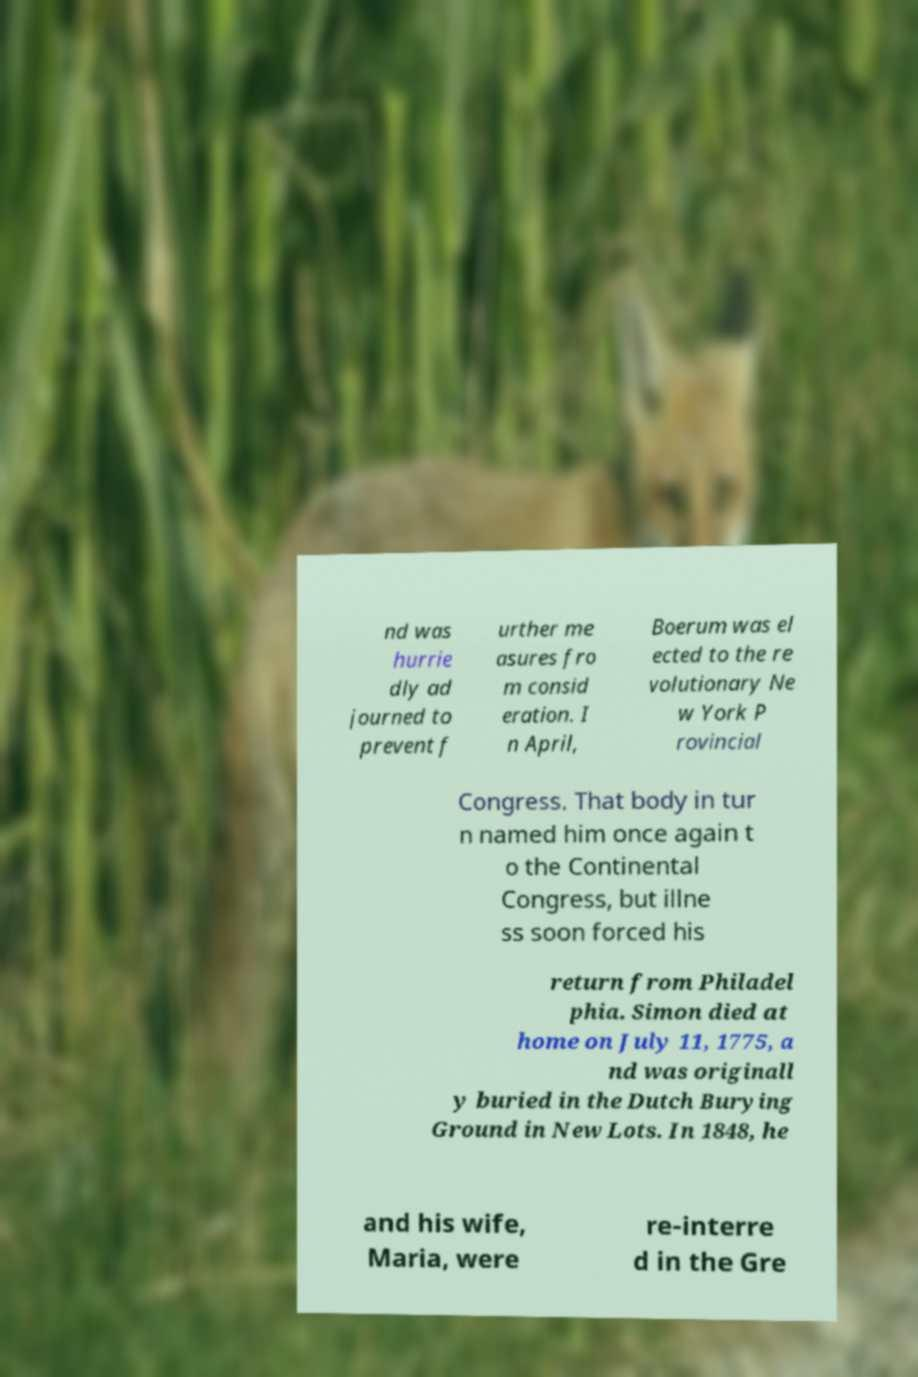For documentation purposes, I need the text within this image transcribed. Could you provide that? nd was hurrie dly ad journed to prevent f urther me asures fro m consid eration. I n April, Boerum was el ected to the re volutionary Ne w York P rovincial Congress. That body in tur n named him once again t o the Continental Congress, but illne ss soon forced his return from Philadel phia. Simon died at home on July 11, 1775, a nd was originall y buried in the Dutch Burying Ground in New Lots. In 1848, he and his wife, Maria, were re-interre d in the Gre 